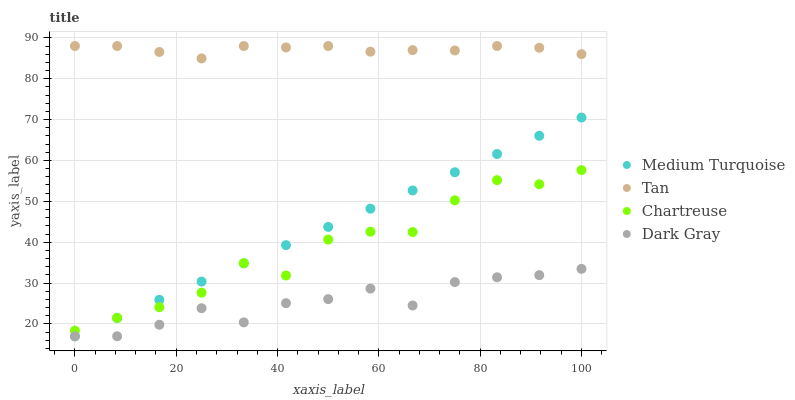Does Dark Gray have the minimum area under the curve?
Answer yes or no. Yes. Does Tan have the maximum area under the curve?
Answer yes or no. Yes. Does Chartreuse have the minimum area under the curve?
Answer yes or no. No. Does Chartreuse have the maximum area under the curve?
Answer yes or no. No. Is Medium Turquoise the smoothest?
Answer yes or no. Yes. Is Chartreuse the roughest?
Answer yes or no. Yes. Is Tan the smoothest?
Answer yes or no. No. Is Tan the roughest?
Answer yes or no. No. Does Dark Gray have the lowest value?
Answer yes or no. Yes. Does Chartreuse have the lowest value?
Answer yes or no. No. Does Tan have the highest value?
Answer yes or no. Yes. Does Chartreuse have the highest value?
Answer yes or no. No. Is Medium Turquoise less than Tan?
Answer yes or no. Yes. Is Tan greater than Chartreuse?
Answer yes or no. Yes. Does Dark Gray intersect Medium Turquoise?
Answer yes or no. Yes. Is Dark Gray less than Medium Turquoise?
Answer yes or no. No. Is Dark Gray greater than Medium Turquoise?
Answer yes or no. No. Does Medium Turquoise intersect Tan?
Answer yes or no. No. 